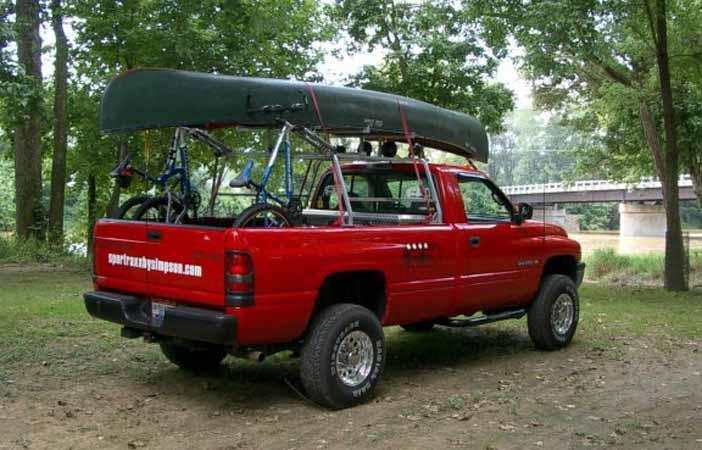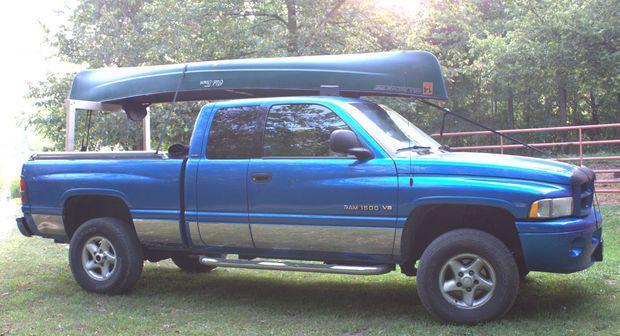The first image is the image on the left, the second image is the image on the right. For the images displayed, is the sentence "A dark green canoe is on top of an open-bed pickup truck." factually correct? Answer yes or no. Yes. 